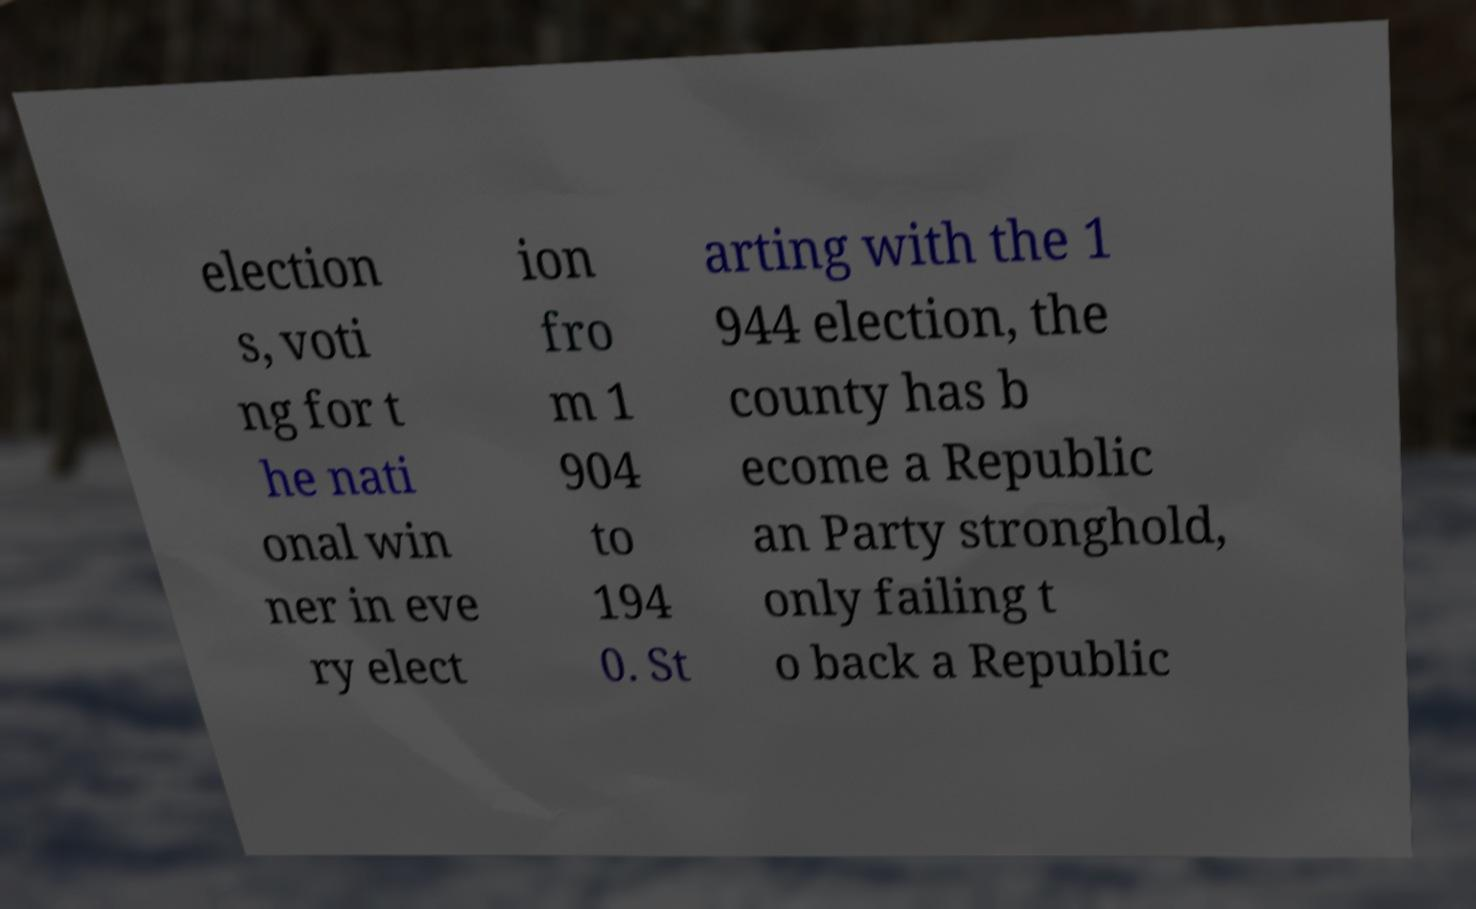Can you read and provide the text displayed in the image?This photo seems to have some interesting text. Can you extract and type it out for me? election s, voti ng for t he nati onal win ner in eve ry elect ion fro m 1 904 to 194 0. St arting with the 1 944 election, the county has b ecome a Republic an Party stronghold, only failing t o back a Republic 